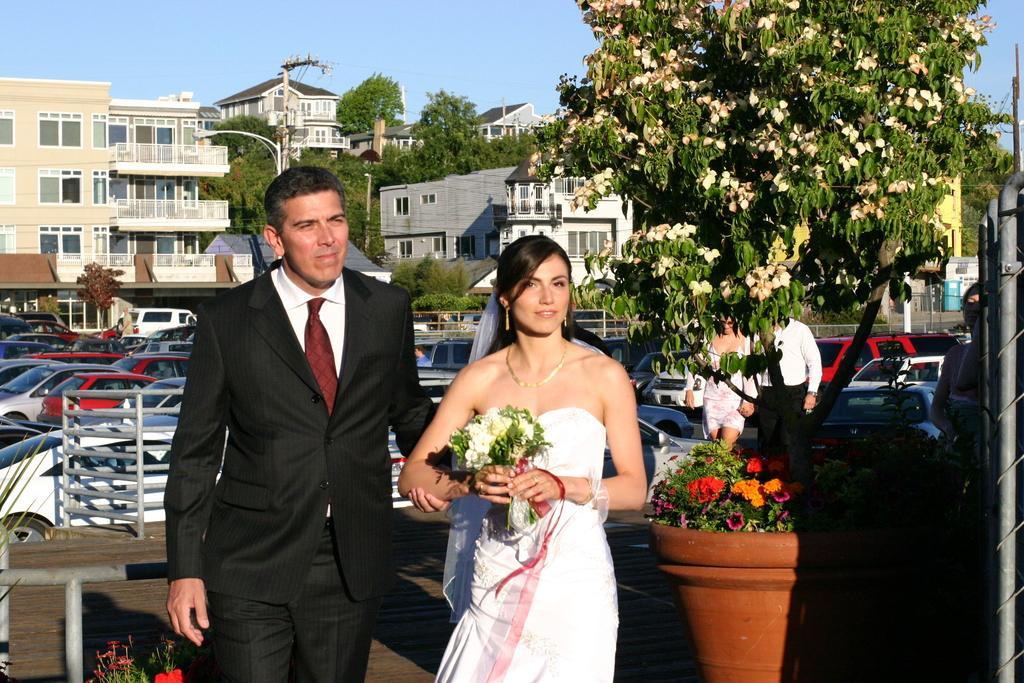How would you summarize this image in a sentence or two? In this image I can see a group of people, house plants, trees and fleets of cars on the road. In the background I can see buildings and the sky. This image is taken may be on the road. 